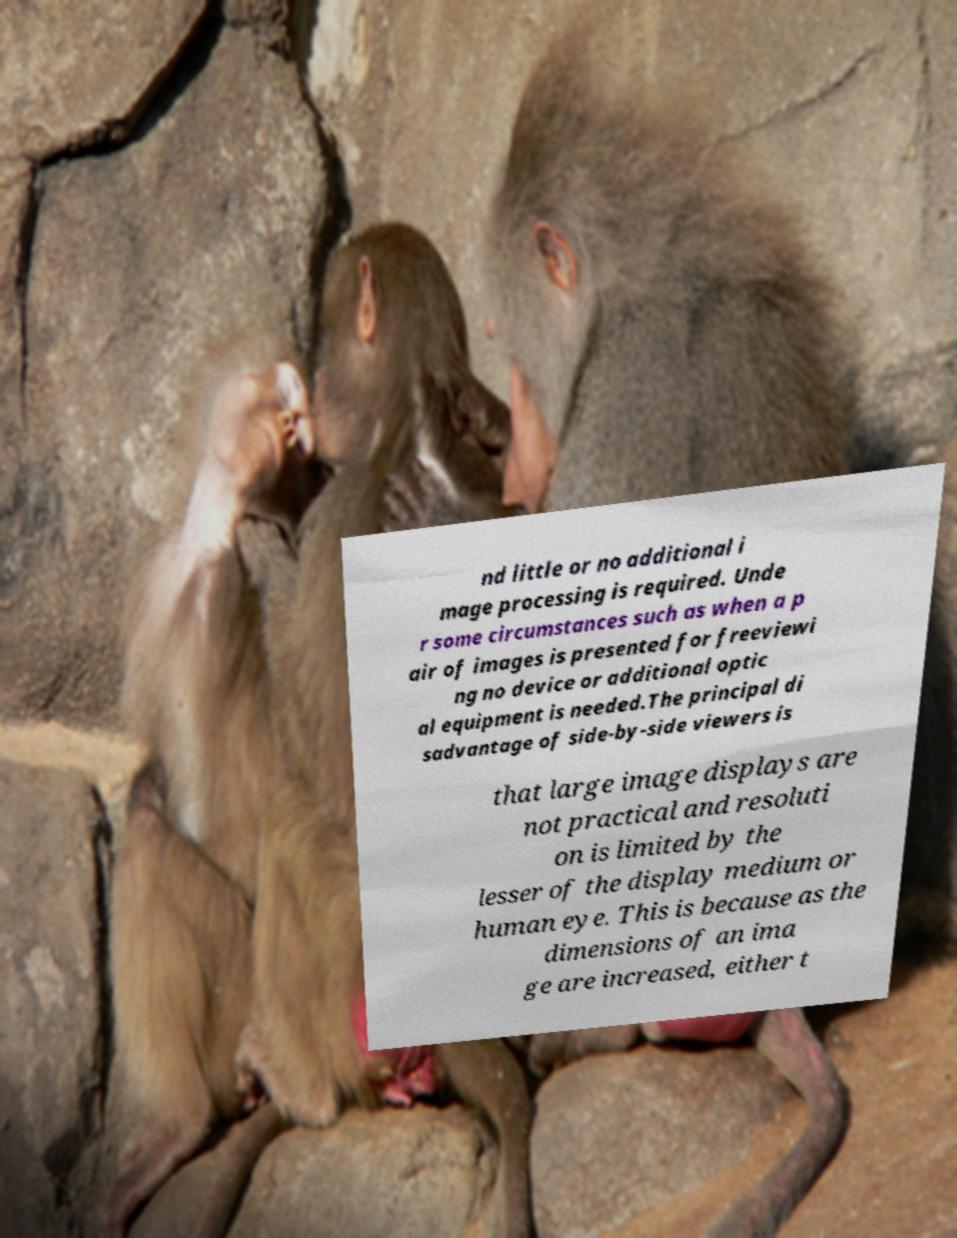For documentation purposes, I need the text within this image transcribed. Could you provide that? nd little or no additional i mage processing is required. Unde r some circumstances such as when a p air of images is presented for freeviewi ng no device or additional optic al equipment is needed.The principal di sadvantage of side-by-side viewers is that large image displays are not practical and resoluti on is limited by the lesser of the display medium or human eye. This is because as the dimensions of an ima ge are increased, either t 